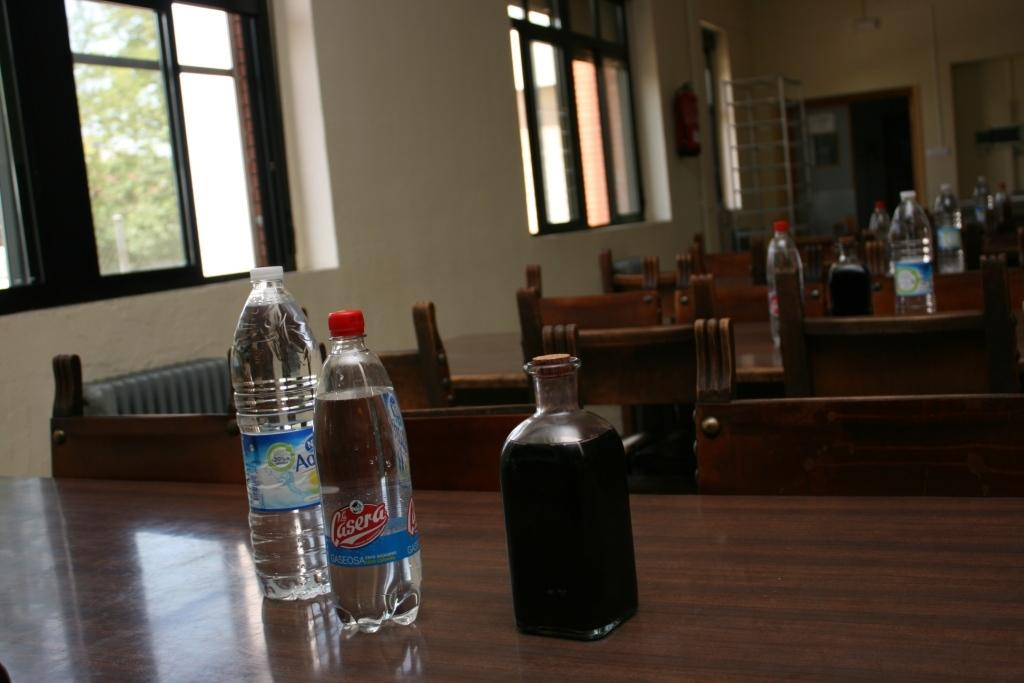<image>
Present a compact description of the photo's key features. A bottle, labelled Casera, is on a table next to others. 